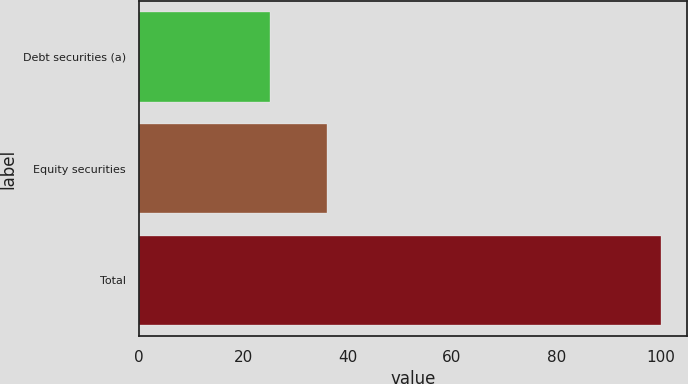<chart> <loc_0><loc_0><loc_500><loc_500><bar_chart><fcel>Debt securities (a)<fcel>Equity securities<fcel>Total<nl><fcel>25<fcel>36<fcel>100<nl></chart> 